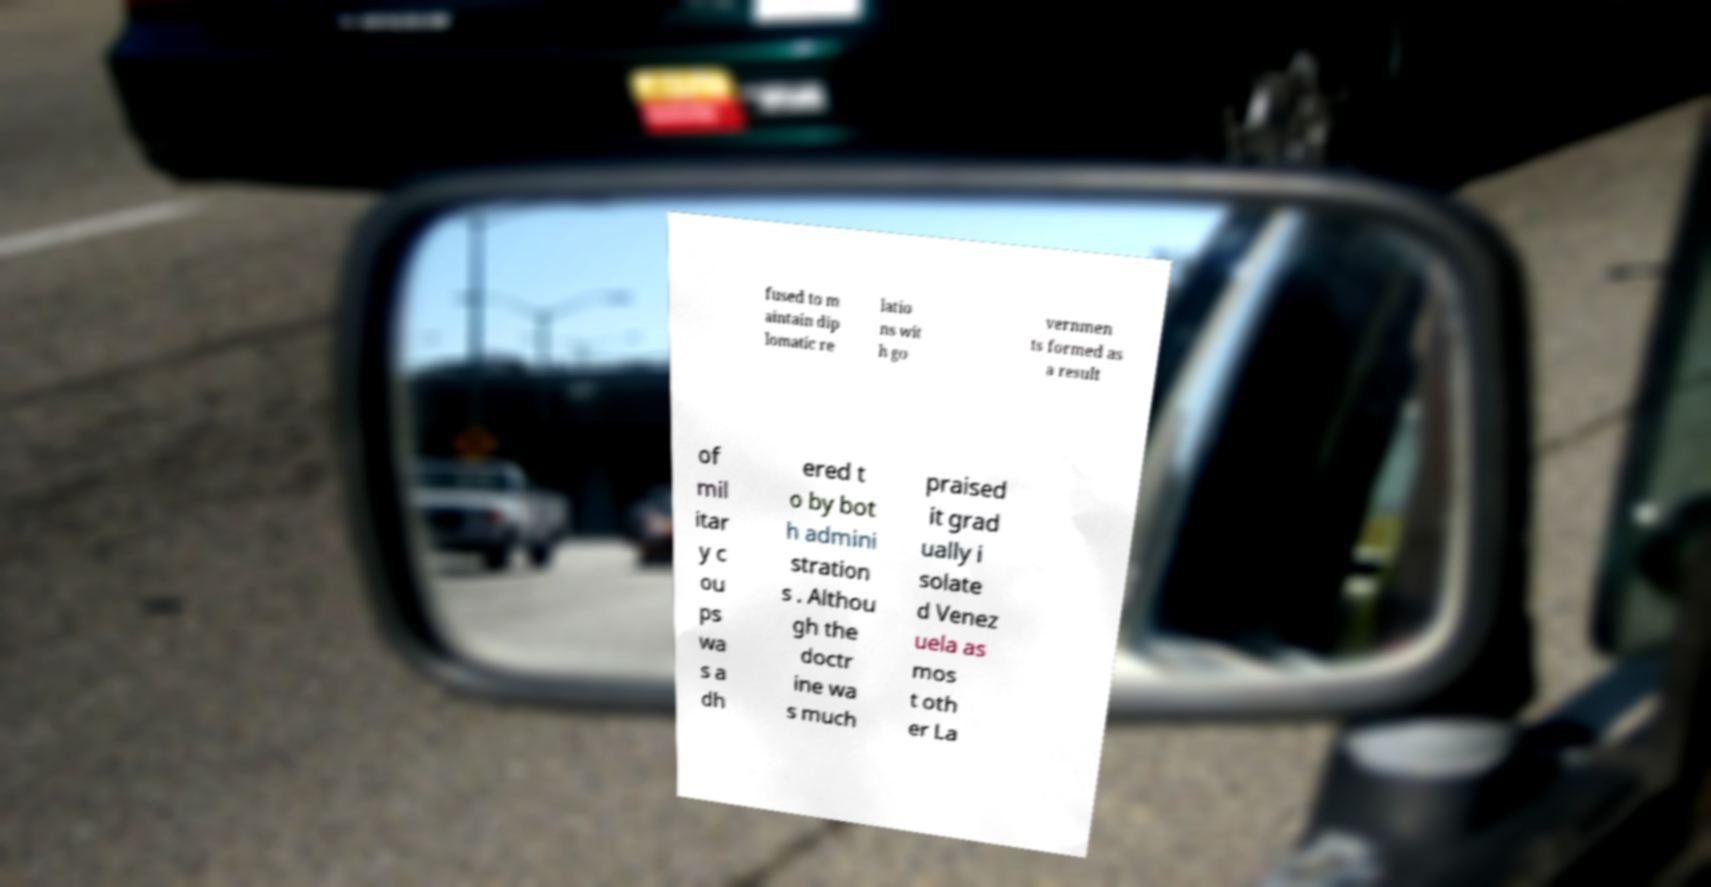What messages or text are displayed in this image? I need them in a readable, typed format. fused to m aintain dip lomatic re latio ns wit h go vernmen ts formed as a result of mil itar y c ou ps wa s a dh ered t o by bot h admini stration s . Althou gh the doctr ine wa s much praised it grad ually i solate d Venez uela as mos t oth er La 